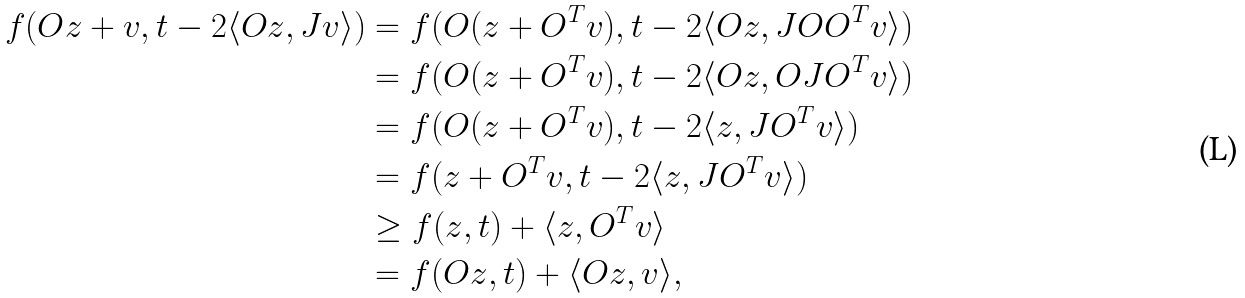<formula> <loc_0><loc_0><loc_500><loc_500>f ( O z + v , t - 2 \langle O z , J v \rangle ) & = f ( O ( z + O ^ { T } v ) , t - 2 \langle O z , J O O ^ { T } v \rangle ) \\ & = f ( O ( z + O ^ { T } v ) , t - 2 \langle O z , O J O ^ { T } v \rangle ) \\ & = f ( O ( z + O ^ { T } v ) , t - 2 \langle z , J O ^ { T } v \rangle ) \\ & = f ( z + O ^ { T } v , t - 2 \langle z , J O ^ { T } v \rangle ) \\ & \geq f ( z , t ) + \langle z , O ^ { T } v \rangle \\ & = f ( O z , t ) + \langle O z , v \rangle ,</formula> 